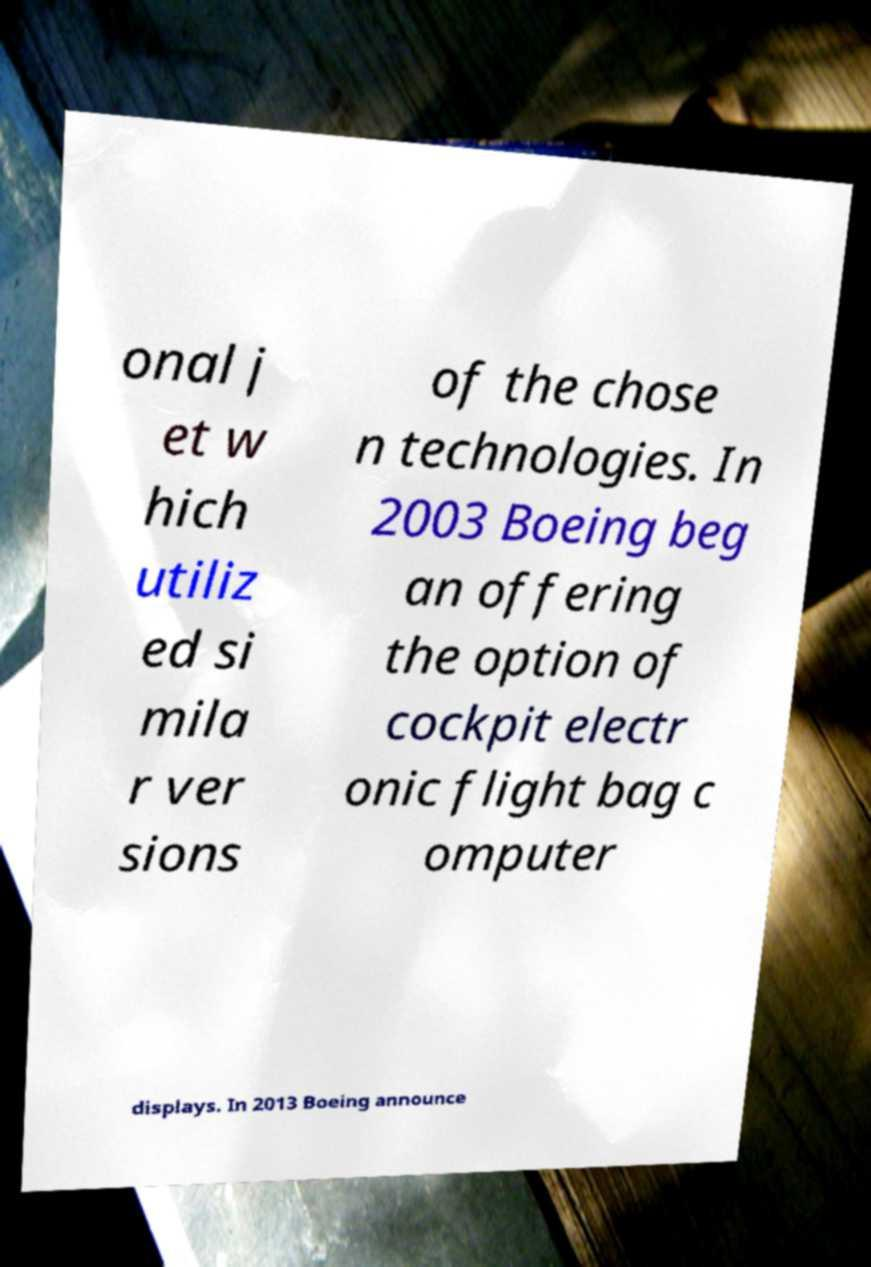There's text embedded in this image that I need extracted. Can you transcribe it verbatim? onal j et w hich utiliz ed si mila r ver sions of the chose n technologies. In 2003 Boeing beg an offering the option of cockpit electr onic flight bag c omputer displays. In 2013 Boeing announce 